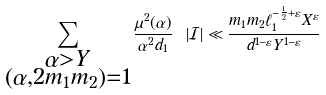<formula> <loc_0><loc_0><loc_500><loc_500>\sum _ { \substack { \alpha > Y \\ ( \alpha , 2 m _ { 1 } m _ { 2 } ) = 1 } } \frac { \mu ^ { 2 } ( \alpha ) } { \alpha ^ { 2 } d _ { 1 } } \ | \mathcal { I } | \ll \frac { m _ { 1 } m _ { 2 } \ell _ { 1 } ^ { - \frac { 1 } { 2 } + \varepsilon } X ^ { \varepsilon } } { d ^ { 1 - \varepsilon } Y ^ { 1 - \varepsilon } }</formula> 